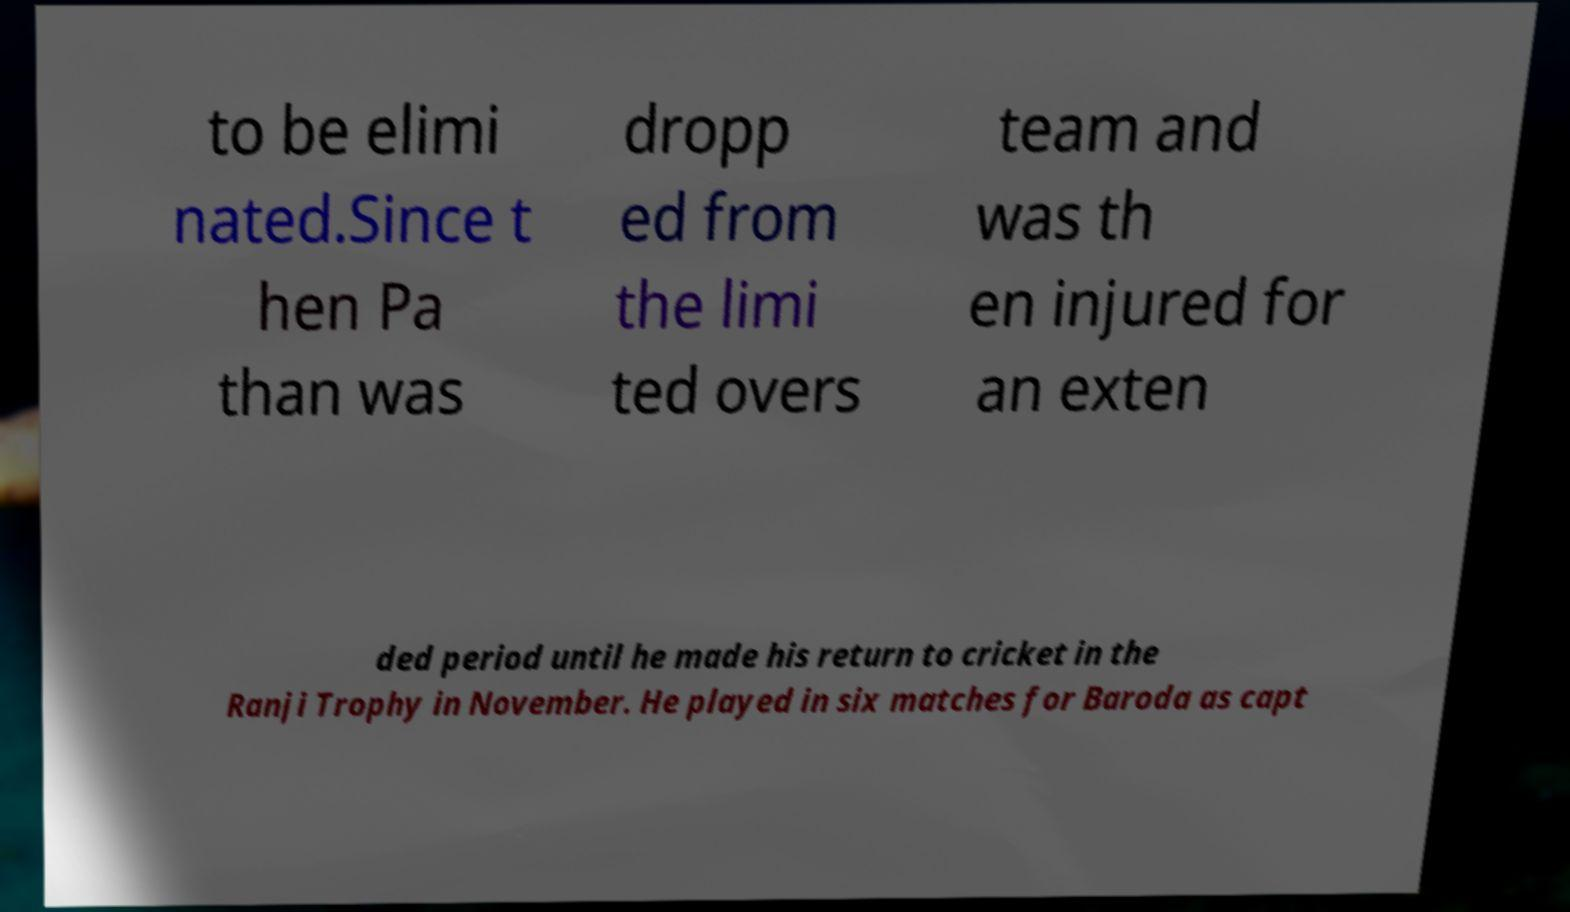Please read and relay the text visible in this image. What does it say? to be elimi nated.Since t hen Pa than was dropp ed from the limi ted overs team and was th en injured for an exten ded period until he made his return to cricket in the Ranji Trophy in November. He played in six matches for Baroda as capt 